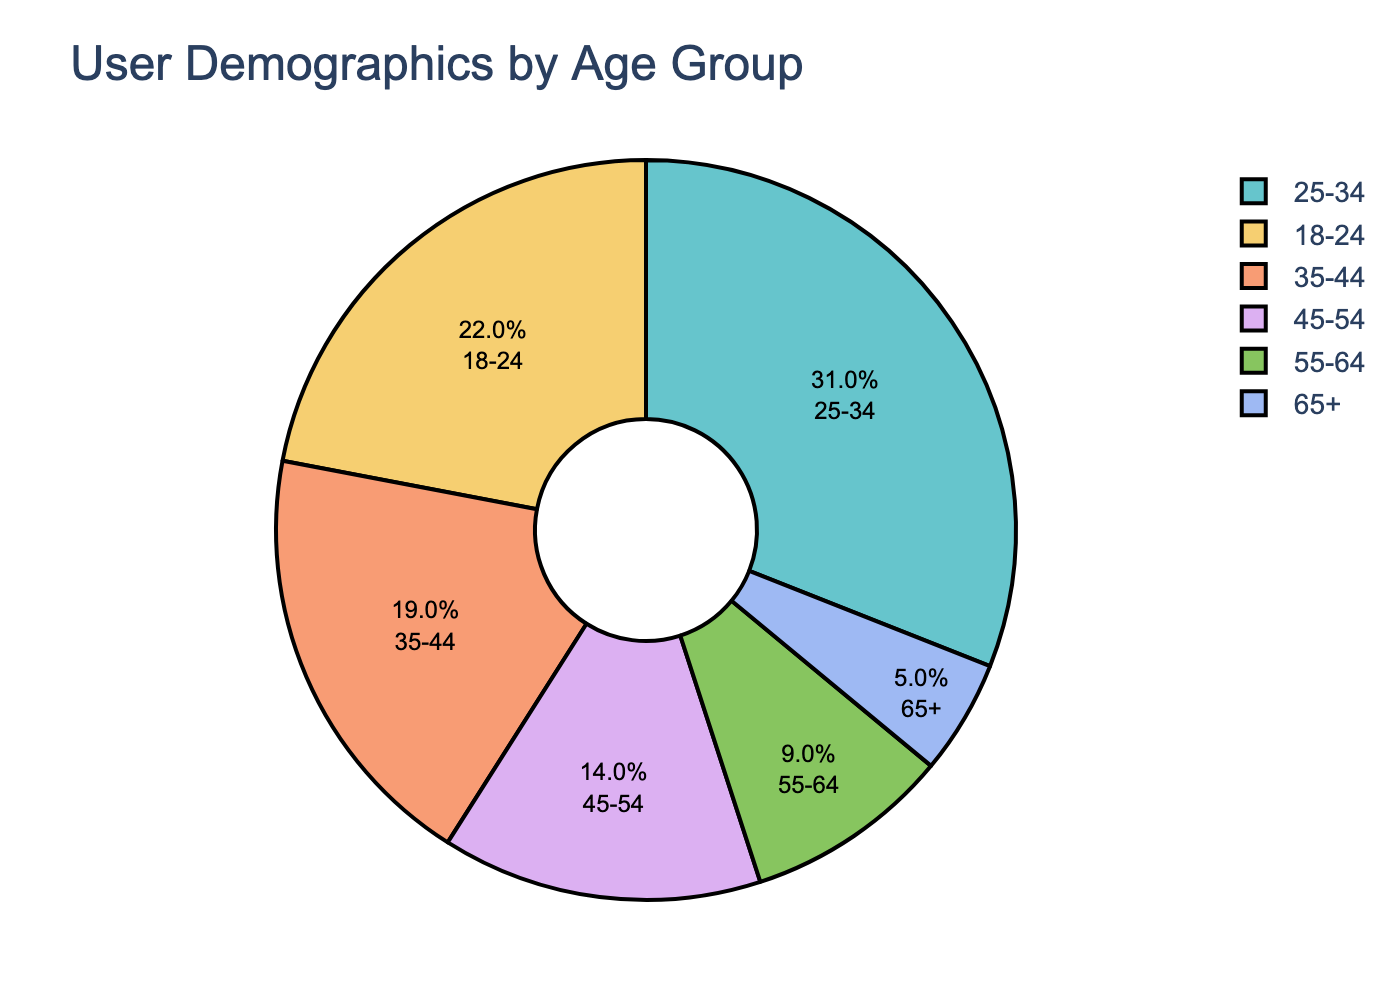What age group is the largest? Look at the pie chart and identify the age group with the largest segment. The 25-34 age group has the largest segment.
Answer: 25-34 What age group is the smallest? Look at the pie chart and identify the age group with the smallest segment. The 65+ age group has the smallest segment.
Answer: 65+ What is the total percentage of users aged 35-44 and 45-54? Add the percentages of the 35-44 and 45-54 age groups: 19% (35-44) + 14% (45-54) = 33%.
Answer: 33% How much larger is the 25-34 age group compared to the 55-64 age group? Subtract the percentage of the 55-64 age group from the 25-34 age group: 31% (25-34) - 9% (55-64) = 22%.
Answer: 22% Which age groups comprise more than half of the users combined? Add the percentages of the largest age groups until the total exceeds 50%. The 18-24 (22%) and 25-34 (31%) age groups together make up 53%.
Answer: 18-24 and 25-34 What are the top three age groups by percentage? Identify the three age groups with the largest percentages: 25-34 (31%), 18-24 (22%), and 35-44 (19%).
Answer: 25-34, 18-24, 35-44 Which age group is represented by a slightly darker color? Observe the pie chart and identify the age group segment that stands out with a slightly darker shade compared to the others.
Answer: Group with 22% (18-24) What is the difference in percentage between the 18-24 and 45-54 age groups? Subtract the percentage of the 45-54 age group from the 18-24 age group: 22% (18-24) - 14% (45-54) = 8%.
Answer: 8% What proportion of users are aged 25-34 and above? Add the percentages of the age groups 25-34 and above: 31% (25-34) + 19% (35-44) + 14% (45-54) + 9% (55-64) + 5% (65+) = 78%.
Answer: 78% How closely in percentage are the 35-44 and 45-54 age groups? Subtract the smaller percentage (45-54) from the larger percentage (35-44): 19% (35-44) - 14% (45-54) = 5%.
Answer: 5% 